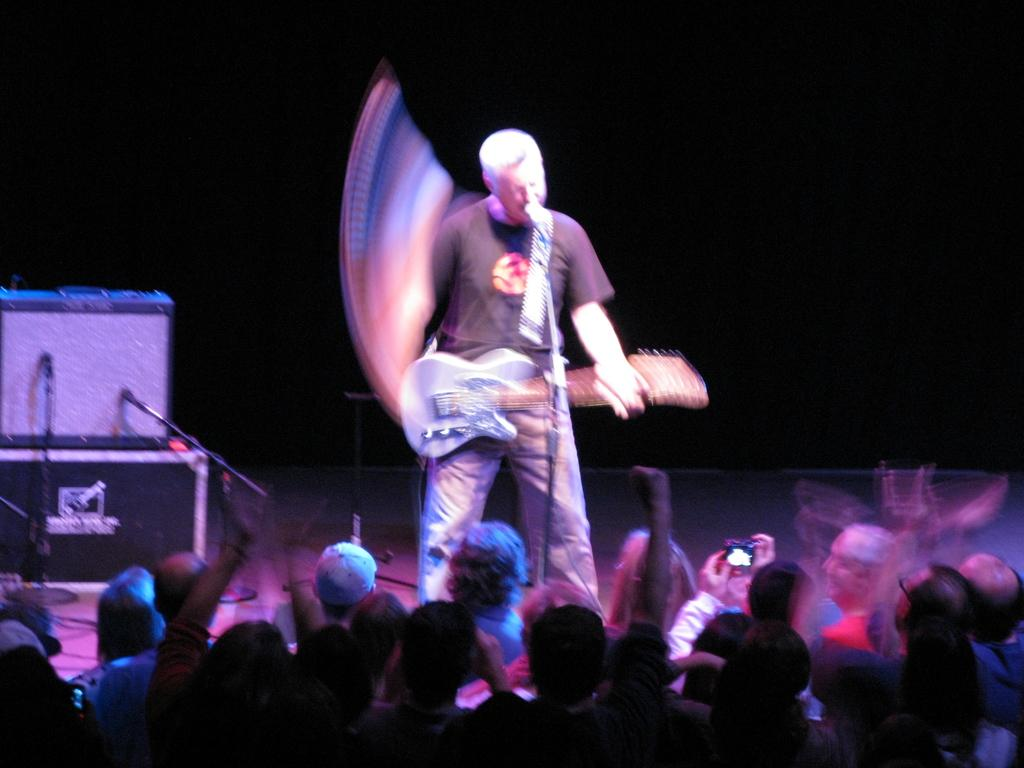What event is taking place in the image? The image appears to depict a concert. Who is the main performer on stage? There is a man standing on the stage. What instrument is the man playing? The man is playing the guitar. What can be seen behind the man on stage? There are equipment behind the man on stage. Who is present in front of the stage? There is a crowd in front of the stage. Can you see a squirrel playing the drums in the image? No, there is no squirrel or drums present in the image. What color is the heart-shaped balloon held by the man on stage? There is no heart-shaped balloon visible in the image. 